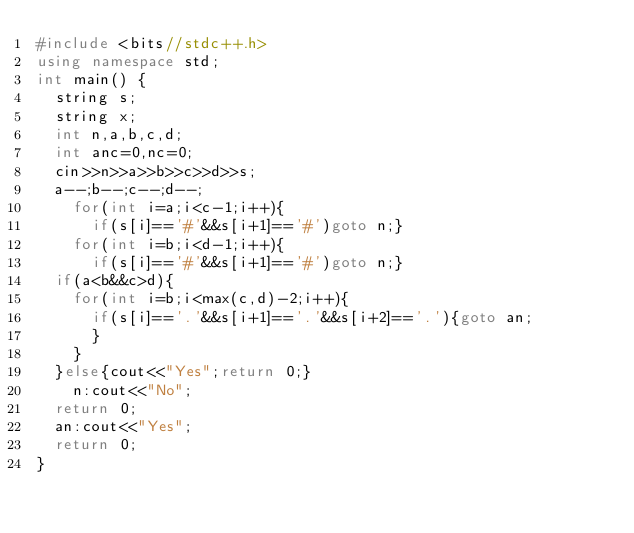<code> <loc_0><loc_0><loc_500><loc_500><_C++_>#include <bits//stdc++.h>
using namespace std;
int main() {
	string s;
	string x;
	int n,a,b,c,d;
	int anc=0,nc=0;
	cin>>n>>a>>b>>c>>d>>s;
  a--;b--;c--;d--;
		for(int i=a;i<c-1;i++){
			if(s[i]=='#'&&s[i+1]=='#')goto n;}
		for(int i=b;i<d-1;i++){
			if(s[i]=='#'&&s[i+1]=='#')goto n;}
	if(a<b&&c>d){
		for(int i=b;i<max(c,d)-2;i++){
			if(s[i]=='.'&&s[i+1]=='.'&&s[i+2]=='.'){goto an;
			}
		}
	}else{cout<<"Yes";return 0;}
    n:cout<<"No";
  return 0;
	an:cout<<"Yes";
	return 0;
}
</code> 